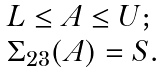Convert formula to latex. <formula><loc_0><loc_0><loc_500><loc_500>\begin{array} { l } L \leq A \leq U ; \\ \Sigma _ { 2 3 } ( A ) = S . \end{array}</formula> 